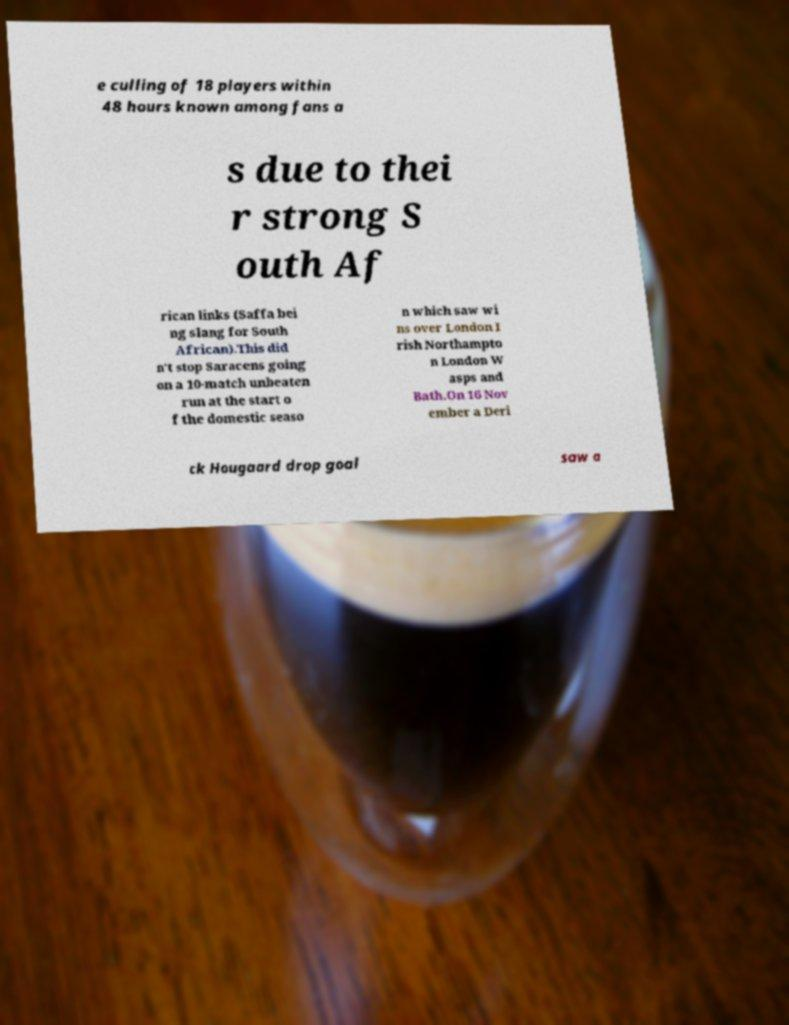I need the written content from this picture converted into text. Can you do that? e culling of 18 players within 48 hours known among fans a s due to thei r strong S outh Af rican links (Saffa bei ng slang for South African).This did n't stop Saracens going on a 10-match unbeaten run at the start o f the domestic seaso n which saw wi ns over London I rish Northampto n London W asps and Bath.On 16 Nov ember a Deri ck Hougaard drop goal saw a 